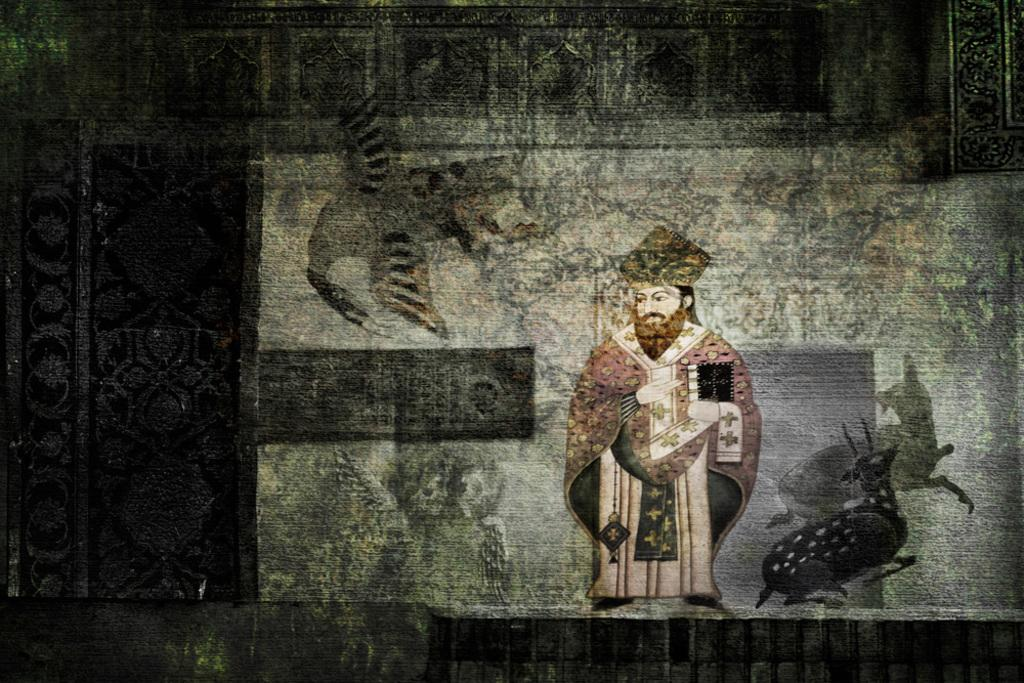What is present on the wall in the image? There are paintings on the wall in the image. What subjects are depicted in the paintings? The paintings depict a person, deers, and other animals. Can you see a stranger wearing a nut and a collar in the image? There is no stranger or any objects like a nut or collar present in the image; the image only features paintings of various subjects. 